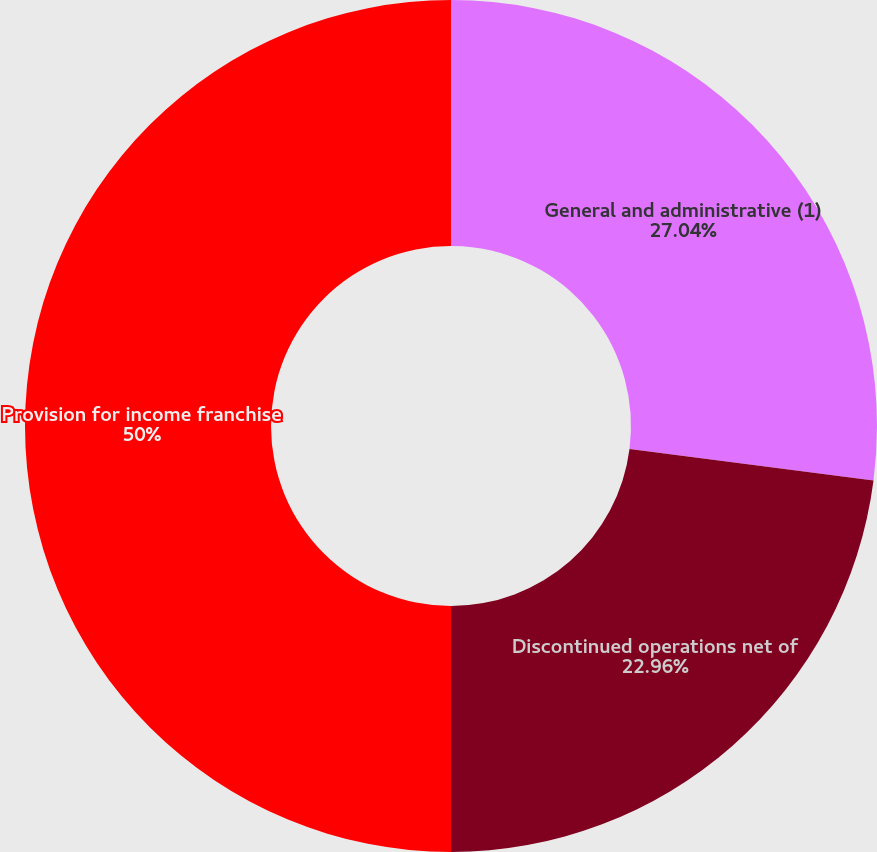<chart> <loc_0><loc_0><loc_500><loc_500><pie_chart><fcel>General and administrative (1)<fcel>Discontinued operations net of<fcel>Provision for income franchise<nl><fcel>27.04%<fcel>22.96%<fcel>50.0%<nl></chart> 